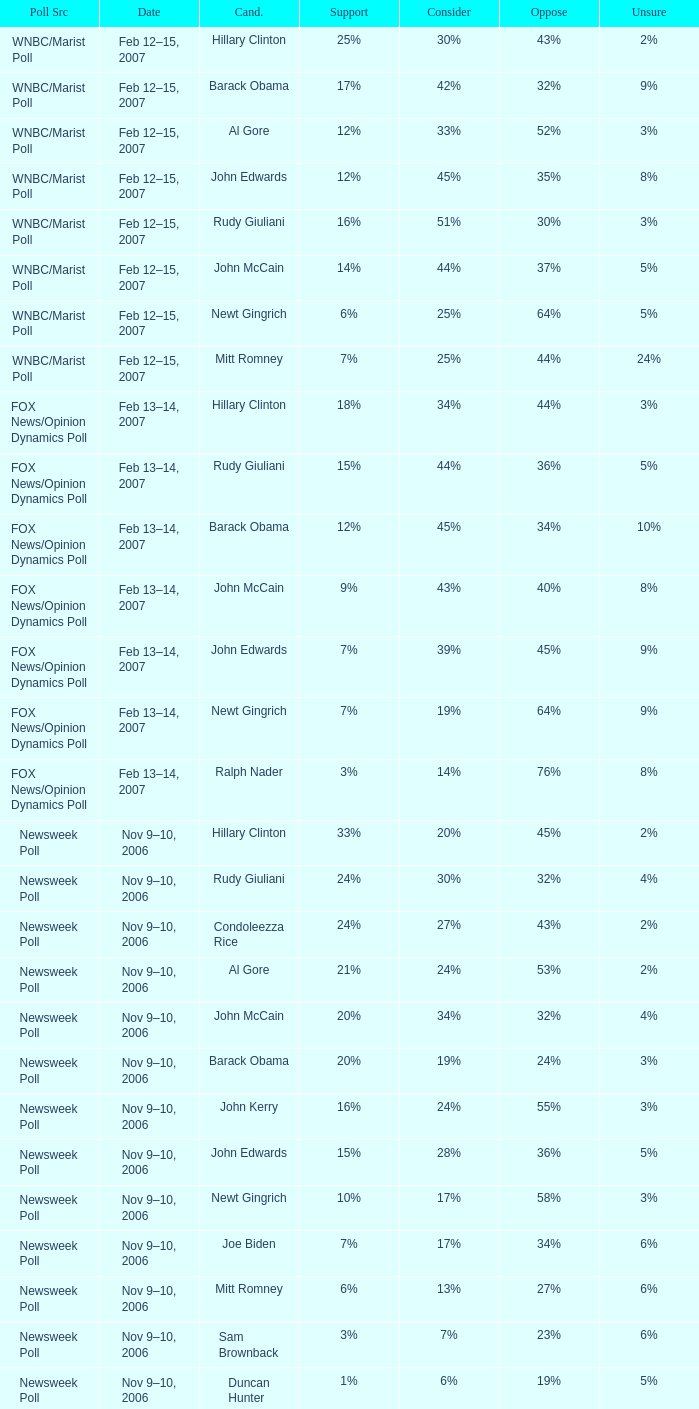In the newsweek poll that indicated 32% opposition, what percentage of respondents expressed they might consider rudy giuliani as a candidate? 30%. Would you be able to parse every entry in this table? {'header': ['Poll Src', 'Date', 'Cand.', 'Support', 'Consider', 'Oppose', 'Unsure'], 'rows': [['WNBC/Marist Poll', 'Feb 12–15, 2007', 'Hillary Clinton', '25%', '30%', '43%', '2%'], ['WNBC/Marist Poll', 'Feb 12–15, 2007', 'Barack Obama', '17%', '42%', '32%', '9%'], ['WNBC/Marist Poll', 'Feb 12–15, 2007', 'Al Gore', '12%', '33%', '52%', '3%'], ['WNBC/Marist Poll', 'Feb 12–15, 2007', 'John Edwards', '12%', '45%', '35%', '8%'], ['WNBC/Marist Poll', 'Feb 12–15, 2007', 'Rudy Giuliani', '16%', '51%', '30%', '3%'], ['WNBC/Marist Poll', 'Feb 12–15, 2007', 'John McCain', '14%', '44%', '37%', '5%'], ['WNBC/Marist Poll', 'Feb 12–15, 2007', 'Newt Gingrich', '6%', '25%', '64%', '5%'], ['WNBC/Marist Poll', 'Feb 12–15, 2007', 'Mitt Romney', '7%', '25%', '44%', '24%'], ['FOX News/Opinion Dynamics Poll', 'Feb 13–14, 2007', 'Hillary Clinton', '18%', '34%', '44%', '3%'], ['FOX News/Opinion Dynamics Poll', 'Feb 13–14, 2007', 'Rudy Giuliani', '15%', '44%', '36%', '5%'], ['FOX News/Opinion Dynamics Poll', 'Feb 13–14, 2007', 'Barack Obama', '12%', '45%', '34%', '10%'], ['FOX News/Opinion Dynamics Poll', 'Feb 13–14, 2007', 'John McCain', '9%', '43%', '40%', '8%'], ['FOX News/Opinion Dynamics Poll', 'Feb 13–14, 2007', 'John Edwards', '7%', '39%', '45%', '9%'], ['FOX News/Opinion Dynamics Poll', 'Feb 13–14, 2007', 'Newt Gingrich', '7%', '19%', '64%', '9%'], ['FOX News/Opinion Dynamics Poll', 'Feb 13–14, 2007', 'Ralph Nader', '3%', '14%', '76%', '8%'], ['Newsweek Poll', 'Nov 9–10, 2006', 'Hillary Clinton', '33%', '20%', '45%', '2%'], ['Newsweek Poll', 'Nov 9–10, 2006', 'Rudy Giuliani', '24%', '30%', '32%', '4%'], ['Newsweek Poll', 'Nov 9–10, 2006', 'Condoleezza Rice', '24%', '27%', '43%', '2%'], ['Newsweek Poll', 'Nov 9–10, 2006', 'Al Gore', '21%', '24%', '53%', '2%'], ['Newsweek Poll', 'Nov 9–10, 2006', 'John McCain', '20%', '34%', '32%', '4%'], ['Newsweek Poll', 'Nov 9–10, 2006', 'Barack Obama', '20%', '19%', '24%', '3%'], ['Newsweek Poll', 'Nov 9–10, 2006', 'John Kerry', '16%', '24%', '55%', '3%'], ['Newsweek Poll', 'Nov 9–10, 2006', 'John Edwards', '15%', '28%', '36%', '5%'], ['Newsweek Poll', 'Nov 9–10, 2006', 'Newt Gingrich', '10%', '17%', '58%', '3%'], ['Newsweek Poll', 'Nov 9–10, 2006', 'Joe Biden', '7%', '17%', '34%', '6%'], ['Newsweek Poll', 'Nov 9–10, 2006', 'Mitt Romney', '6%', '13%', '27%', '6%'], ['Newsweek Poll', 'Nov 9–10, 2006', 'Sam Brownback', '3%', '7%', '23%', '6%'], ['Newsweek Poll', 'Nov 9–10, 2006', 'Duncan Hunter', '1%', '6%', '19%', '5%'], ['Time Poll', 'Oct 3–4, 2006', 'Rudy Giuliani', '17%', '55%', '19%', '18%'], ['Time Poll', 'Oct 3–4, 2006', 'Hillary Rodham Clinton', '23%', '36%', '37%', '5%'], ['Time Poll', 'Oct 3–4, 2006', 'John McCain', '12%', '56%', '19%', '13%'], ['Time Poll', 'Oct 3–4, 2006', 'Al Gore', '16%', '44%', '35%', '5%'], ['Time Poll', 'Oct 3–4, 2006', 'John Kerry', '14%', '43%', '34%', '9%'], ['Time Poll', 'Jul 13–17, 2006', 'Rudy Giuliani', '17%', '54%', '14%', '15%'], ['Time Poll', 'Jul 13–17, 2006', 'Hillary Rodham Clinton', '19%', '41%', '34%', '6%'], ['Time Poll', 'Jul 13–17, 2006', 'John McCain', '12%', '52%', '13%', '22%'], ['Time Poll', 'Jul 13–17, 2006', 'Al Gore', '16%', '45%', '32%', '7%'], ['Time Poll', 'Jul 13–17, 2006', 'John Kerry', '12%', '48%', '30%', '10%'], ['CNN Poll', 'Jun 1–6, 2006', 'Hillary Rodham Clinton', '22%', '28%', '47%', '3%'], ['CNN Poll', 'Jun 1–6, 2006', 'Al Gore', '17%', '32%', '48%', '3%'], ['CNN Poll', 'Jun 1–6, 2006', 'John Kerry', '14%', '35%', '47%', '4%'], ['CNN Poll', 'Jun 1–6, 2006', 'Rudolph Giuliani', '19%', '45%', '30%', '6%'], ['CNN Poll', 'Jun 1–6, 2006', 'John McCain', '12%', '48%', '34%', '6%'], ['CNN Poll', 'Jun 1–6, 2006', 'Jeb Bush', '9%', '26%', '63%', '2%'], ['ABC News/Washington Post Poll', 'May 11–15, 2006', 'Hillary Clinton', '19%', '38%', '42%', '1%'], ['ABC News/Washington Post Poll', 'May 11–15, 2006', 'John McCain', '9%', '57%', '28%', '6%'], ['FOX News/Opinion Dynamics Poll', 'Feb 7–8, 2006', 'Hillary Clinton', '35%', '19%', '44%', '2%'], ['FOX News/Opinion Dynamics Poll', 'Feb 7–8, 2006', 'Rudy Giuliani', '33%', '38%', '24%', '6%'], ['FOX News/Opinion Dynamics Poll', 'Feb 7–8, 2006', 'John McCain', '30%', '40%', '22%', '7%'], ['FOX News/Opinion Dynamics Poll', 'Feb 7–8, 2006', 'John Kerry', '29%', '23%', '45%', '3%'], ['FOX News/Opinion Dynamics Poll', 'Feb 7–8, 2006', 'Condoleezza Rice', '14%', '38%', '46%', '3%'], ['CNN/USA Today/Gallup Poll', 'Jan 20–22, 2006', 'Hillary Rodham Clinton', '16%', '32%', '51%', '1%'], ['Diageo/Hotline Poll', 'Nov 11–15, 2005', 'John McCain', '23%', '46%', '15%', '15%'], ['CNN/USA Today/Gallup Poll', 'May 20–22, 2005', 'Hillary Rodham Clinton', '28%', '31%', '40%', '1%'], ['CNN/USA Today/Gallup Poll', 'Jun 9–10, 2003', 'Hillary Rodham Clinton', '20%', '33%', '45%', '2%']]} 